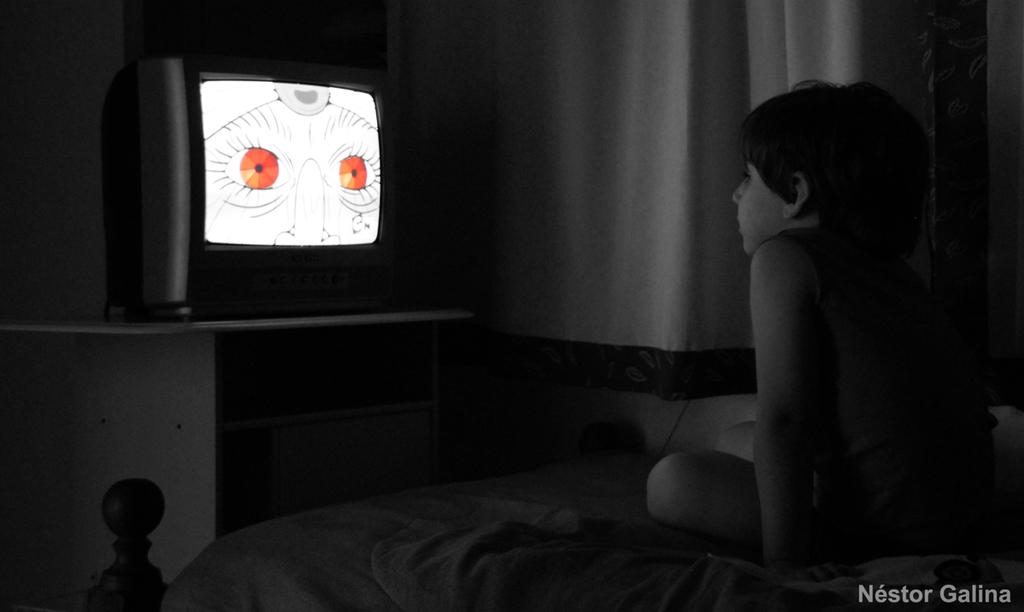Who is the main subject in the image? There is a child in the image. What is the child doing in the image? The child is sitting on a bed and watching television. What type of jellyfish can be seen swimming in the background of the image? There is no jellyfish present in the image; it features a child sitting on a bed and watching television. 